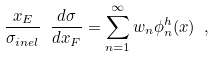Convert formula to latex. <formula><loc_0><loc_0><loc_500><loc_500>\frac { x _ { E } } { \sigma _ { i n e l } } \ \frac { d \sigma } { d x _ { F } } = \sum _ { n = 1 } ^ { \infty } w _ { n } \phi _ { n } ^ { h } ( x ) \ ,</formula> 